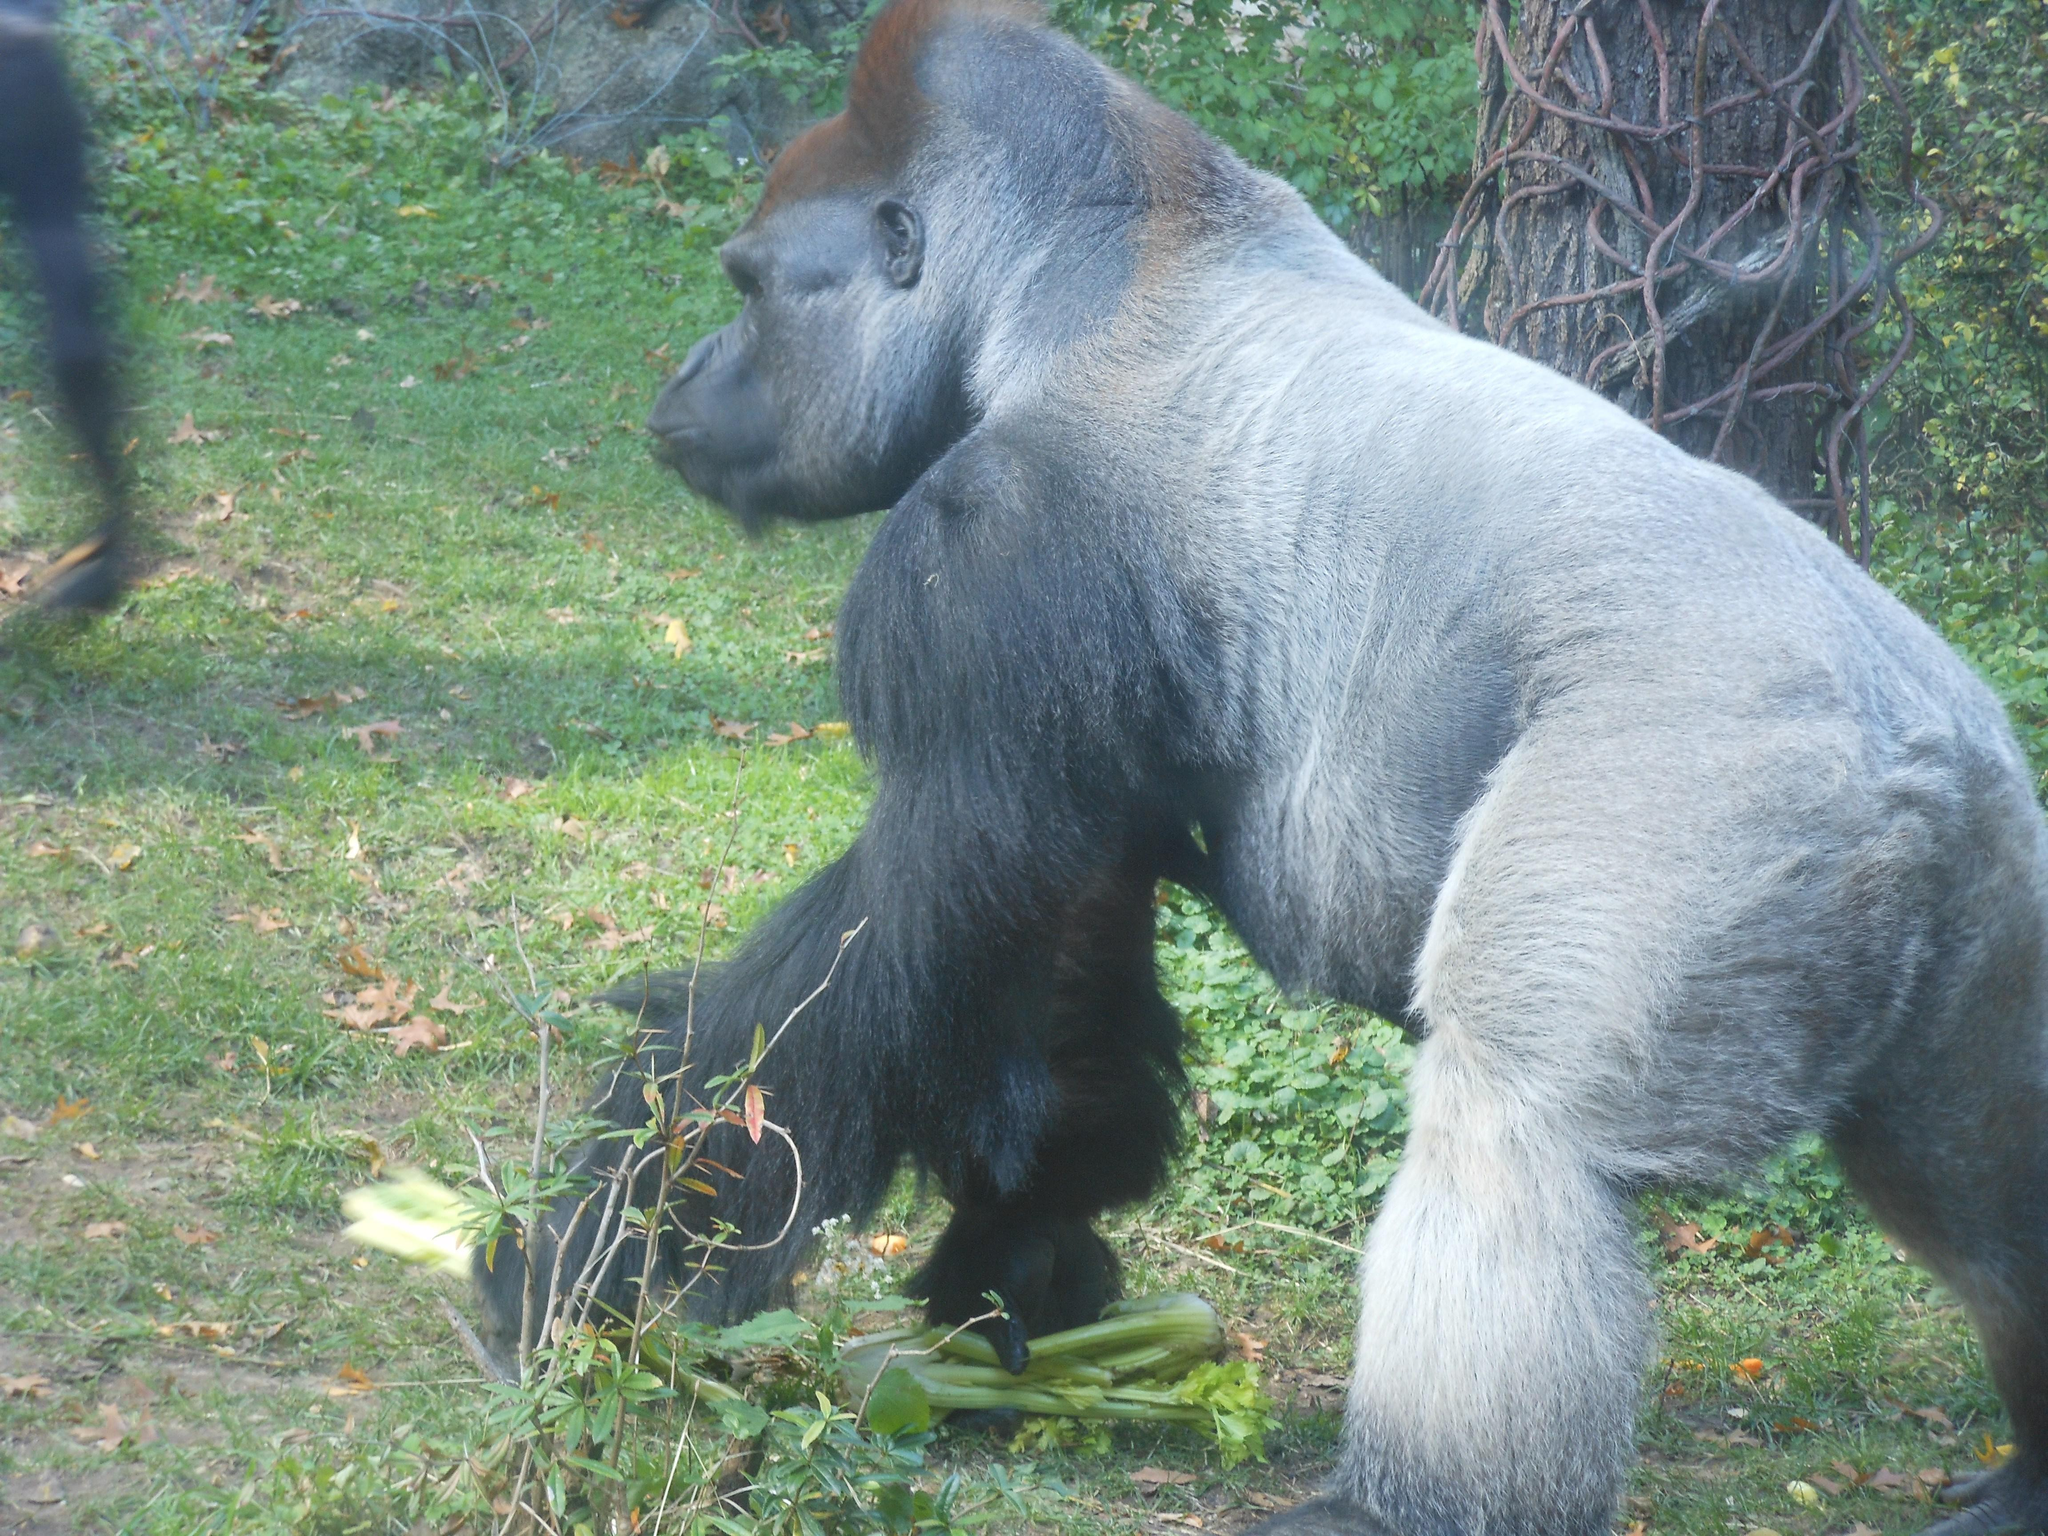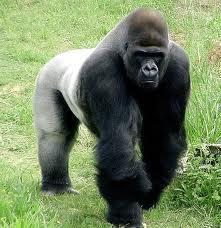The first image is the image on the left, the second image is the image on the right. Considering the images on both sides, is "Multiple gorillas can be seen in the right image." valid? Answer yes or no. No. The first image is the image on the left, the second image is the image on the right. Analyze the images presented: Is the assertion "An image includes a baby gorilla held in the arms of an adult gorilla." valid? Answer yes or no. No. 